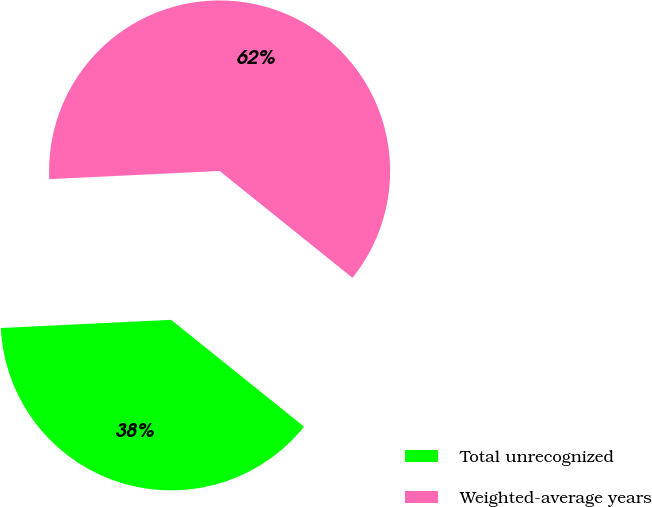<chart> <loc_0><loc_0><loc_500><loc_500><pie_chart><fcel>Total unrecognized<fcel>Weighted-average years<nl><fcel>38.46%<fcel>61.54%<nl></chart> 